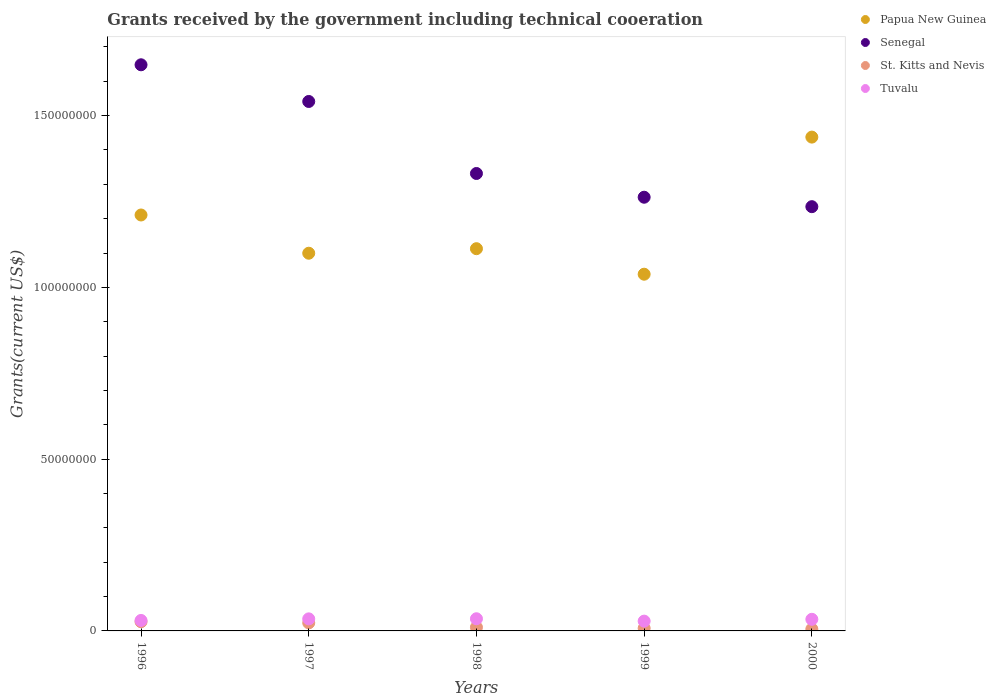Is the number of dotlines equal to the number of legend labels?
Provide a succinct answer. Yes. What is the total grants received by the government in Tuvalu in 1999?
Ensure brevity in your answer.  2.85e+06. Across all years, what is the maximum total grants received by the government in Senegal?
Provide a succinct answer. 1.65e+08. Across all years, what is the minimum total grants received by the government in Papua New Guinea?
Offer a very short reply. 1.04e+08. What is the total total grants received by the government in Tuvalu in the graph?
Your answer should be compact. 1.63e+07. What is the difference between the total grants received by the government in Tuvalu in 1997 and that in 1998?
Your answer should be compact. -3.00e+04. What is the difference between the total grants received by the government in Tuvalu in 1999 and the total grants received by the government in Senegal in 1996?
Your response must be concise. -1.62e+08. What is the average total grants received by the government in St. Kitts and Nevis per year?
Make the answer very short. 1.48e+06. In the year 1999, what is the difference between the total grants received by the government in Papua New Guinea and total grants received by the government in Senegal?
Provide a succinct answer. -2.24e+07. In how many years, is the total grants received by the government in St. Kitts and Nevis greater than 130000000 US$?
Your response must be concise. 0. What is the ratio of the total grants received by the government in St. Kitts and Nevis in 1998 to that in 1999?
Your answer should be compact. 1.35. Is the total grants received by the government in Papua New Guinea in 1996 less than that in 1998?
Offer a terse response. No. What is the difference between the highest and the second highest total grants received by the government in Senegal?
Make the answer very short. 1.07e+07. What is the difference between the highest and the lowest total grants received by the government in Papua New Guinea?
Offer a terse response. 3.99e+07. In how many years, is the total grants received by the government in Tuvalu greater than the average total grants received by the government in Tuvalu taken over all years?
Offer a very short reply. 3. Is the total grants received by the government in Senegal strictly less than the total grants received by the government in Papua New Guinea over the years?
Give a very brief answer. No. Does the graph contain grids?
Keep it short and to the point. No. Where does the legend appear in the graph?
Your response must be concise. Top right. How many legend labels are there?
Provide a succinct answer. 4. What is the title of the graph?
Provide a short and direct response. Grants received by the government including technical cooeration. What is the label or title of the Y-axis?
Offer a terse response. Grants(current US$). What is the Grants(current US$) in Papua New Guinea in 1996?
Provide a succinct answer. 1.21e+08. What is the Grants(current US$) in Senegal in 1996?
Your answer should be compact. 1.65e+08. What is the Grants(current US$) in St. Kitts and Nevis in 1996?
Keep it short and to the point. 2.67e+06. What is the Grants(current US$) in Tuvalu in 1996?
Provide a succinct answer. 3.05e+06. What is the Grants(current US$) of Papua New Guinea in 1997?
Your answer should be very brief. 1.10e+08. What is the Grants(current US$) in Senegal in 1997?
Offer a very short reply. 1.54e+08. What is the Grants(current US$) of St. Kitts and Nevis in 1997?
Your answer should be very brief. 2.34e+06. What is the Grants(current US$) of Tuvalu in 1997?
Your response must be concise. 3.51e+06. What is the Grants(current US$) in Papua New Guinea in 1998?
Give a very brief answer. 1.11e+08. What is the Grants(current US$) in Senegal in 1998?
Ensure brevity in your answer.  1.33e+08. What is the Grants(current US$) in St. Kitts and Nevis in 1998?
Offer a terse response. 1.05e+06. What is the Grants(current US$) in Tuvalu in 1998?
Your answer should be compact. 3.54e+06. What is the Grants(current US$) of Papua New Guinea in 1999?
Your response must be concise. 1.04e+08. What is the Grants(current US$) of Senegal in 1999?
Keep it short and to the point. 1.26e+08. What is the Grants(current US$) in St. Kitts and Nevis in 1999?
Your response must be concise. 7.80e+05. What is the Grants(current US$) in Tuvalu in 1999?
Keep it short and to the point. 2.85e+06. What is the Grants(current US$) of Papua New Guinea in 2000?
Make the answer very short. 1.44e+08. What is the Grants(current US$) in Senegal in 2000?
Provide a short and direct response. 1.23e+08. What is the Grants(current US$) of Tuvalu in 2000?
Ensure brevity in your answer.  3.38e+06. Across all years, what is the maximum Grants(current US$) of Papua New Guinea?
Ensure brevity in your answer.  1.44e+08. Across all years, what is the maximum Grants(current US$) in Senegal?
Your response must be concise. 1.65e+08. Across all years, what is the maximum Grants(current US$) of St. Kitts and Nevis?
Your answer should be compact. 2.67e+06. Across all years, what is the maximum Grants(current US$) in Tuvalu?
Offer a very short reply. 3.54e+06. Across all years, what is the minimum Grants(current US$) in Papua New Guinea?
Offer a very short reply. 1.04e+08. Across all years, what is the minimum Grants(current US$) in Senegal?
Offer a very short reply. 1.23e+08. Across all years, what is the minimum Grants(current US$) in Tuvalu?
Your response must be concise. 2.85e+06. What is the total Grants(current US$) in Papua New Guinea in the graph?
Keep it short and to the point. 5.90e+08. What is the total Grants(current US$) of Senegal in the graph?
Your answer should be compact. 7.02e+08. What is the total Grants(current US$) in St. Kitts and Nevis in the graph?
Ensure brevity in your answer.  7.39e+06. What is the total Grants(current US$) of Tuvalu in the graph?
Your response must be concise. 1.63e+07. What is the difference between the Grants(current US$) in Papua New Guinea in 1996 and that in 1997?
Keep it short and to the point. 1.11e+07. What is the difference between the Grants(current US$) of Senegal in 1996 and that in 1997?
Your answer should be very brief. 1.07e+07. What is the difference between the Grants(current US$) of Tuvalu in 1996 and that in 1997?
Your response must be concise. -4.60e+05. What is the difference between the Grants(current US$) in Papua New Guinea in 1996 and that in 1998?
Make the answer very short. 9.81e+06. What is the difference between the Grants(current US$) of Senegal in 1996 and that in 1998?
Keep it short and to the point. 3.16e+07. What is the difference between the Grants(current US$) of St. Kitts and Nevis in 1996 and that in 1998?
Ensure brevity in your answer.  1.62e+06. What is the difference between the Grants(current US$) of Tuvalu in 1996 and that in 1998?
Ensure brevity in your answer.  -4.90e+05. What is the difference between the Grants(current US$) of Papua New Guinea in 1996 and that in 1999?
Give a very brief answer. 1.72e+07. What is the difference between the Grants(current US$) of Senegal in 1996 and that in 1999?
Offer a very short reply. 3.86e+07. What is the difference between the Grants(current US$) of St. Kitts and Nevis in 1996 and that in 1999?
Give a very brief answer. 1.89e+06. What is the difference between the Grants(current US$) in Papua New Guinea in 1996 and that in 2000?
Provide a succinct answer. -2.27e+07. What is the difference between the Grants(current US$) of Senegal in 1996 and that in 2000?
Provide a short and direct response. 4.13e+07. What is the difference between the Grants(current US$) in St. Kitts and Nevis in 1996 and that in 2000?
Ensure brevity in your answer.  2.12e+06. What is the difference between the Grants(current US$) in Tuvalu in 1996 and that in 2000?
Your response must be concise. -3.30e+05. What is the difference between the Grants(current US$) of Papua New Guinea in 1997 and that in 1998?
Ensure brevity in your answer.  -1.32e+06. What is the difference between the Grants(current US$) in Senegal in 1997 and that in 1998?
Ensure brevity in your answer.  2.10e+07. What is the difference between the Grants(current US$) of St. Kitts and Nevis in 1997 and that in 1998?
Offer a very short reply. 1.29e+06. What is the difference between the Grants(current US$) in Tuvalu in 1997 and that in 1998?
Provide a short and direct response. -3.00e+04. What is the difference between the Grants(current US$) of Papua New Guinea in 1997 and that in 1999?
Offer a terse response. 6.11e+06. What is the difference between the Grants(current US$) in Senegal in 1997 and that in 1999?
Provide a succinct answer. 2.79e+07. What is the difference between the Grants(current US$) in St. Kitts and Nevis in 1997 and that in 1999?
Provide a succinct answer. 1.56e+06. What is the difference between the Grants(current US$) of Tuvalu in 1997 and that in 1999?
Give a very brief answer. 6.60e+05. What is the difference between the Grants(current US$) of Papua New Guinea in 1997 and that in 2000?
Give a very brief answer. -3.38e+07. What is the difference between the Grants(current US$) in Senegal in 1997 and that in 2000?
Provide a succinct answer. 3.06e+07. What is the difference between the Grants(current US$) in St. Kitts and Nevis in 1997 and that in 2000?
Provide a short and direct response. 1.79e+06. What is the difference between the Grants(current US$) of Papua New Guinea in 1998 and that in 1999?
Offer a very short reply. 7.43e+06. What is the difference between the Grants(current US$) in Senegal in 1998 and that in 1999?
Offer a very short reply. 6.91e+06. What is the difference between the Grants(current US$) of St. Kitts and Nevis in 1998 and that in 1999?
Give a very brief answer. 2.70e+05. What is the difference between the Grants(current US$) in Tuvalu in 1998 and that in 1999?
Keep it short and to the point. 6.90e+05. What is the difference between the Grants(current US$) in Papua New Guinea in 1998 and that in 2000?
Make the answer very short. -3.25e+07. What is the difference between the Grants(current US$) of Senegal in 1998 and that in 2000?
Your answer should be very brief. 9.66e+06. What is the difference between the Grants(current US$) in Tuvalu in 1998 and that in 2000?
Make the answer very short. 1.60e+05. What is the difference between the Grants(current US$) of Papua New Guinea in 1999 and that in 2000?
Your answer should be compact. -3.99e+07. What is the difference between the Grants(current US$) in Senegal in 1999 and that in 2000?
Provide a succinct answer. 2.75e+06. What is the difference between the Grants(current US$) in Tuvalu in 1999 and that in 2000?
Keep it short and to the point. -5.30e+05. What is the difference between the Grants(current US$) in Papua New Guinea in 1996 and the Grants(current US$) in Senegal in 1997?
Provide a short and direct response. -3.30e+07. What is the difference between the Grants(current US$) in Papua New Guinea in 1996 and the Grants(current US$) in St. Kitts and Nevis in 1997?
Give a very brief answer. 1.19e+08. What is the difference between the Grants(current US$) in Papua New Guinea in 1996 and the Grants(current US$) in Tuvalu in 1997?
Your answer should be very brief. 1.18e+08. What is the difference between the Grants(current US$) of Senegal in 1996 and the Grants(current US$) of St. Kitts and Nevis in 1997?
Ensure brevity in your answer.  1.62e+08. What is the difference between the Grants(current US$) of Senegal in 1996 and the Grants(current US$) of Tuvalu in 1997?
Offer a very short reply. 1.61e+08. What is the difference between the Grants(current US$) of St. Kitts and Nevis in 1996 and the Grants(current US$) of Tuvalu in 1997?
Your answer should be compact. -8.40e+05. What is the difference between the Grants(current US$) in Papua New Guinea in 1996 and the Grants(current US$) in Senegal in 1998?
Offer a very short reply. -1.21e+07. What is the difference between the Grants(current US$) in Papua New Guinea in 1996 and the Grants(current US$) in St. Kitts and Nevis in 1998?
Ensure brevity in your answer.  1.20e+08. What is the difference between the Grants(current US$) of Papua New Guinea in 1996 and the Grants(current US$) of Tuvalu in 1998?
Keep it short and to the point. 1.18e+08. What is the difference between the Grants(current US$) of Senegal in 1996 and the Grants(current US$) of St. Kitts and Nevis in 1998?
Provide a short and direct response. 1.64e+08. What is the difference between the Grants(current US$) in Senegal in 1996 and the Grants(current US$) in Tuvalu in 1998?
Ensure brevity in your answer.  1.61e+08. What is the difference between the Grants(current US$) in St. Kitts and Nevis in 1996 and the Grants(current US$) in Tuvalu in 1998?
Your answer should be compact. -8.70e+05. What is the difference between the Grants(current US$) of Papua New Guinea in 1996 and the Grants(current US$) of Senegal in 1999?
Make the answer very short. -5.17e+06. What is the difference between the Grants(current US$) of Papua New Guinea in 1996 and the Grants(current US$) of St. Kitts and Nevis in 1999?
Your answer should be compact. 1.20e+08. What is the difference between the Grants(current US$) of Papua New Guinea in 1996 and the Grants(current US$) of Tuvalu in 1999?
Your answer should be very brief. 1.18e+08. What is the difference between the Grants(current US$) in Senegal in 1996 and the Grants(current US$) in St. Kitts and Nevis in 1999?
Your answer should be compact. 1.64e+08. What is the difference between the Grants(current US$) in Senegal in 1996 and the Grants(current US$) in Tuvalu in 1999?
Give a very brief answer. 1.62e+08. What is the difference between the Grants(current US$) in St. Kitts and Nevis in 1996 and the Grants(current US$) in Tuvalu in 1999?
Offer a terse response. -1.80e+05. What is the difference between the Grants(current US$) of Papua New Guinea in 1996 and the Grants(current US$) of Senegal in 2000?
Offer a very short reply. -2.42e+06. What is the difference between the Grants(current US$) in Papua New Guinea in 1996 and the Grants(current US$) in St. Kitts and Nevis in 2000?
Make the answer very short. 1.21e+08. What is the difference between the Grants(current US$) in Papua New Guinea in 1996 and the Grants(current US$) in Tuvalu in 2000?
Offer a terse response. 1.18e+08. What is the difference between the Grants(current US$) of Senegal in 1996 and the Grants(current US$) of St. Kitts and Nevis in 2000?
Ensure brevity in your answer.  1.64e+08. What is the difference between the Grants(current US$) of Senegal in 1996 and the Grants(current US$) of Tuvalu in 2000?
Offer a terse response. 1.61e+08. What is the difference between the Grants(current US$) in St. Kitts and Nevis in 1996 and the Grants(current US$) in Tuvalu in 2000?
Your response must be concise. -7.10e+05. What is the difference between the Grants(current US$) in Papua New Guinea in 1997 and the Grants(current US$) in Senegal in 1998?
Offer a terse response. -2.32e+07. What is the difference between the Grants(current US$) of Papua New Guinea in 1997 and the Grants(current US$) of St. Kitts and Nevis in 1998?
Offer a very short reply. 1.09e+08. What is the difference between the Grants(current US$) of Papua New Guinea in 1997 and the Grants(current US$) of Tuvalu in 1998?
Give a very brief answer. 1.06e+08. What is the difference between the Grants(current US$) of Senegal in 1997 and the Grants(current US$) of St. Kitts and Nevis in 1998?
Provide a short and direct response. 1.53e+08. What is the difference between the Grants(current US$) in Senegal in 1997 and the Grants(current US$) in Tuvalu in 1998?
Your answer should be compact. 1.51e+08. What is the difference between the Grants(current US$) in St. Kitts and Nevis in 1997 and the Grants(current US$) in Tuvalu in 1998?
Your response must be concise. -1.20e+06. What is the difference between the Grants(current US$) in Papua New Guinea in 1997 and the Grants(current US$) in Senegal in 1999?
Ensure brevity in your answer.  -1.63e+07. What is the difference between the Grants(current US$) of Papua New Guinea in 1997 and the Grants(current US$) of St. Kitts and Nevis in 1999?
Provide a succinct answer. 1.09e+08. What is the difference between the Grants(current US$) in Papua New Guinea in 1997 and the Grants(current US$) in Tuvalu in 1999?
Offer a very short reply. 1.07e+08. What is the difference between the Grants(current US$) in Senegal in 1997 and the Grants(current US$) in St. Kitts and Nevis in 1999?
Give a very brief answer. 1.53e+08. What is the difference between the Grants(current US$) in Senegal in 1997 and the Grants(current US$) in Tuvalu in 1999?
Keep it short and to the point. 1.51e+08. What is the difference between the Grants(current US$) in St. Kitts and Nevis in 1997 and the Grants(current US$) in Tuvalu in 1999?
Offer a very short reply. -5.10e+05. What is the difference between the Grants(current US$) of Papua New Guinea in 1997 and the Grants(current US$) of Senegal in 2000?
Make the answer very short. -1.36e+07. What is the difference between the Grants(current US$) in Papua New Guinea in 1997 and the Grants(current US$) in St. Kitts and Nevis in 2000?
Your answer should be very brief. 1.09e+08. What is the difference between the Grants(current US$) in Papua New Guinea in 1997 and the Grants(current US$) in Tuvalu in 2000?
Offer a terse response. 1.07e+08. What is the difference between the Grants(current US$) in Senegal in 1997 and the Grants(current US$) in St. Kitts and Nevis in 2000?
Provide a succinct answer. 1.54e+08. What is the difference between the Grants(current US$) of Senegal in 1997 and the Grants(current US$) of Tuvalu in 2000?
Your response must be concise. 1.51e+08. What is the difference between the Grants(current US$) in St. Kitts and Nevis in 1997 and the Grants(current US$) in Tuvalu in 2000?
Make the answer very short. -1.04e+06. What is the difference between the Grants(current US$) of Papua New Guinea in 1998 and the Grants(current US$) of Senegal in 1999?
Make the answer very short. -1.50e+07. What is the difference between the Grants(current US$) of Papua New Guinea in 1998 and the Grants(current US$) of St. Kitts and Nevis in 1999?
Make the answer very short. 1.10e+08. What is the difference between the Grants(current US$) in Papua New Guinea in 1998 and the Grants(current US$) in Tuvalu in 1999?
Your answer should be compact. 1.08e+08. What is the difference between the Grants(current US$) of Senegal in 1998 and the Grants(current US$) of St. Kitts and Nevis in 1999?
Offer a terse response. 1.32e+08. What is the difference between the Grants(current US$) in Senegal in 1998 and the Grants(current US$) in Tuvalu in 1999?
Your answer should be compact. 1.30e+08. What is the difference between the Grants(current US$) in St. Kitts and Nevis in 1998 and the Grants(current US$) in Tuvalu in 1999?
Keep it short and to the point. -1.80e+06. What is the difference between the Grants(current US$) in Papua New Guinea in 1998 and the Grants(current US$) in Senegal in 2000?
Offer a very short reply. -1.22e+07. What is the difference between the Grants(current US$) of Papua New Guinea in 1998 and the Grants(current US$) of St. Kitts and Nevis in 2000?
Keep it short and to the point. 1.11e+08. What is the difference between the Grants(current US$) of Papua New Guinea in 1998 and the Grants(current US$) of Tuvalu in 2000?
Keep it short and to the point. 1.08e+08. What is the difference between the Grants(current US$) in Senegal in 1998 and the Grants(current US$) in St. Kitts and Nevis in 2000?
Ensure brevity in your answer.  1.33e+08. What is the difference between the Grants(current US$) in Senegal in 1998 and the Grants(current US$) in Tuvalu in 2000?
Provide a succinct answer. 1.30e+08. What is the difference between the Grants(current US$) of St. Kitts and Nevis in 1998 and the Grants(current US$) of Tuvalu in 2000?
Your response must be concise. -2.33e+06. What is the difference between the Grants(current US$) in Papua New Guinea in 1999 and the Grants(current US$) in Senegal in 2000?
Offer a terse response. -1.97e+07. What is the difference between the Grants(current US$) in Papua New Guinea in 1999 and the Grants(current US$) in St. Kitts and Nevis in 2000?
Offer a very short reply. 1.03e+08. What is the difference between the Grants(current US$) in Papua New Guinea in 1999 and the Grants(current US$) in Tuvalu in 2000?
Make the answer very short. 1.00e+08. What is the difference between the Grants(current US$) of Senegal in 1999 and the Grants(current US$) of St. Kitts and Nevis in 2000?
Offer a terse response. 1.26e+08. What is the difference between the Grants(current US$) of Senegal in 1999 and the Grants(current US$) of Tuvalu in 2000?
Ensure brevity in your answer.  1.23e+08. What is the difference between the Grants(current US$) of St. Kitts and Nevis in 1999 and the Grants(current US$) of Tuvalu in 2000?
Provide a short and direct response. -2.60e+06. What is the average Grants(current US$) in Papua New Guinea per year?
Provide a succinct answer. 1.18e+08. What is the average Grants(current US$) of Senegal per year?
Your response must be concise. 1.40e+08. What is the average Grants(current US$) of St. Kitts and Nevis per year?
Provide a succinct answer. 1.48e+06. What is the average Grants(current US$) in Tuvalu per year?
Offer a terse response. 3.27e+06. In the year 1996, what is the difference between the Grants(current US$) of Papua New Guinea and Grants(current US$) of Senegal?
Provide a short and direct response. -4.37e+07. In the year 1996, what is the difference between the Grants(current US$) of Papua New Guinea and Grants(current US$) of St. Kitts and Nevis?
Your answer should be compact. 1.18e+08. In the year 1996, what is the difference between the Grants(current US$) in Papua New Guinea and Grants(current US$) in Tuvalu?
Make the answer very short. 1.18e+08. In the year 1996, what is the difference between the Grants(current US$) in Senegal and Grants(current US$) in St. Kitts and Nevis?
Keep it short and to the point. 1.62e+08. In the year 1996, what is the difference between the Grants(current US$) of Senegal and Grants(current US$) of Tuvalu?
Make the answer very short. 1.62e+08. In the year 1996, what is the difference between the Grants(current US$) of St. Kitts and Nevis and Grants(current US$) of Tuvalu?
Provide a succinct answer. -3.80e+05. In the year 1997, what is the difference between the Grants(current US$) in Papua New Guinea and Grants(current US$) in Senegal?
Your answer should be very brief. -4.42e+07. In the year 1997, what is the difference between the Grants(current US$) of Papua New Guinea and Grants(current US$) of St. Kitts and Nevis?
Ensure brevity in your answer.  1.08e+08. In the year 1997, what is the difference between the Grants(current US$) of Papua New Guinea and Grants(current US$) of Tuvalu?
Offer a very short reply. 1.06e+08. In the year 1997, what is the difference between the Grants(current US$) of Senegal and Grants(current US$) of St. Kitts and Nevis?
Make the answer very short. 1.52e+08. In the year 1997, what is the difference between the Grants(current US$) in Senegal and Grants(current US$) in Tuvalu?
Ensure brevity in your answer.  1.51e+08. In the year 1997, what is the difference between the Grants(current US$) of St. Kitts and Nevis and Grants(current US$) of Tuvalu?
Provide a short and direct response. -1.17e+06. In the year 1998, what is the difference between the Grants(current US$) of Papua New Guinea and Grants(current US$) of Senegal?
Offer a very short reply. -2.19e+07. In the year 1998, what is the difference between the Grants(current US$) in Papua New Guinea and Grants(current US$) in St. Kitts and Nevis?
Provide a short and direct response. 1.10e+08. In the year 1998, what is the difference between the Grants(current US$) in Papua New Guinea and Grants(current US$) in Tuvalu?
Keep it short and to the point. 1.08e+08. In the year 1998, what is the difference between the Grants(current US$) of Senegal and Grants(current US$) of St. Kitts and Nevis?
Give a very brief answer. 1.32e+08. In the year 1998, what is the difference between the Grants(current US$) of Senegal and Grants(current US$) of Tuvalu?
Your response must be concise. 1.30e+08. In the year 1998, what is the difference between the Grants(current US$) in St. Kitts and Nevis and Grants(current US$) in Tuvalu?
Your response must be concise. -2.49e+06. In the year 1999, what is the difference between the Grants(current US$) of Papua New Guinea and Grants(current US$) of Senegal?
Your answer should be very brief. -2.24e+07. In the year 1999, what is the difference between the Grants(current US$) in Papua New Guinea and Grants(current US$) in St. Kitts and Nevis?
Your answer should be very brief. 1.03e+08. In the year 1999, what is the difference between the Grants(current US$) in Papua New Guinea and Grants(current US$) in Tuvalu?
Give a very brief answer. 1.01e+08. In the year 1999, what is the difference between the Grants(current US$) of Senegal and Grants(current US$) of St. Kitts and Nevis?
Your answer should be compact. 1.25e+08. In the year 1999, what is the difference between the Grants(current US$) of Senegal and Grants(current US$) of Tuvalu?
Your response must be concise. 1.23e+08. In the year 1999, what is the difference between the Grants(current US$) in St. Kitts and Nevis and Grants(current US$) in Tuvalu?
Make the answer very short. -2.07e+06. In the year 2000, what is the difference between the Grants(current US$) in Papua New Guinea and Grants(current US$) in Senegal?
Provide a short and direct response. 2.02e+07. In the year 2000, what is the difference between the Grants(current US$) in Papua New Guinea and Grants(current US$) in St. Kitts and Nevis?
Offer a very short reply. 1.43e+08. In the year 2000, what is the difference between the Grants(current US$) of Papua New Guinea and Grants(current US$) of Tuvalu?
Give a very brief answer. 1.40e+08. In the year 2000, what is the difference between the Grants(current US$) in Senegal and Grants(current US$) in St. Kitts and Nevis?
Your response must be concise. 1.23e+08. In the year 2000, what is the difference between the Grants(current US$) of Senegal and Grants(current US$) of Tuvalu?
Provide a short and direct response. 1.20e+08. In the year 2000, what is the difference between the Grants(current US$) in St. Kitts and Nevis and Grants(current US$) in Tuvalu?
Your answer should be very brief. -2.83e+06. What is the ratio of the Grants(current US$) in Papua New Guinea in 1996 to that in 1997?
Your response must be concise. 1.1. What is the ratio of the Grants(current US$) of Senegal in 1996 to that in 1997?
Offer a terse response. 1.07. What is the ratio of the Grants(current US$) in St. Kitts and Nevis in 1996 to that in 1997?
Give a very brief answer. 1.14. What is the ratio of the Grants(current US$) of Tuvalu in 1996 to that in 1997?
Give a very brief answer. 0.87. What is the ratio of the Grants(current US$) in Papua New Guinea in 1996 to that in 1998?
Ensure brevity in your answer.  1.09. What is the ratio of the Grants(current US$) in Senegal in 1996 to that in 1998?
Offer a terse response. 1.24. What is the ratio of the Grants(current US$) in St. Kitts and Nevis in 1996 to that in 1998?
Offer a very short reply. 2.54. What is the ratio of the Grants(current US$) in Tuvalu in 1996 to that in 1998?
Give a very brief answer. 0.86. What is the ratio of the Grants(current US$) in Papua New Guinea in 1996 to that in 1999?
Offer a very short reply. 1.17. What is the ratio of the Grants(current US$) of Senegal in 1996 to that in 1999?
Provide a short and direct response. 1.31. What is the ratio of the Grants(current US$) in St. Kitts and Nevis in 1996 to that in 1999?
Ensure brevity in your answer.  3.42. What is the ratio of the Grants(current US$) in Tuvalu in 1996 to that in 1999?
Offer a terse response. 1.07. What is the ratio of the Grants(current US$) in Papua New Guinea in 1996 to that in 2000?
Provide a succinct answer. 0.84. What is the ratio of the Grants(current US$) in Senegal in 1996 to that in 2000?
Provide a short and direct response. 1.33. What is the ratio of the Grants(current US$) of St. Kitts and Nevis in 1996 to that in 2000?
Offer a terse response. 4.85. What is the ratio of the Grants(current US$) of Tuvalu in 1996 to that in 2000?
Your answer should be compact. 0.9. What is the ratio of the Grants(current US$) of Papua New Guinea in 1997 to that in 1998?
Your answer should be very brief. 0.99. What is the ratio of the Grants(current US$) of Senegal in 1997 to that in 1998?
Ensure brevity in your answer.  1.16. What is the ratio of the Grants(current US$) in St. Kitts and Nevis in 1997 to that in 1998?
Your response must be concise. 2.23. What is the ratio of the Grants(current US$) in Papua New Guinea in 1997 to that in 1999?
Offer a very short reply. 1.06. What is the ratio of the Grants(current US$) in Senegal in 1997 to that in 1999?
Give a very brief answer. 1.22. What is the ratio of the Grants(current US$) in St. Kitts and Nevis in 1997 to that in 1999?
Your answer should be compact. 3. What is the ratio of the Grants(current US$) in Tuvalu in 1997 to that in 1999?
Offer a terse response. 1.23. What is the ratio of the Grants(current US$) in Papua New Guinea in 1997 to that in 2000?
Your answer should be very brief. 0.76. What is the ratio of the Grants(current US$) of Senegal in 1997 to that in 2000?
Your response must be concise. 1.25. What is the ratio of the Grants(current US$) of St. Kitts and Nevis in 1997 to that in 2000?
Ensure brevity in your answer.  4.25. What is the ratio of the Grants(current US$) of Tuvalu in 1997 to that in 2000?
Your answer should be very brief. 1.04. What is the ratio of the Grants(current US$) of Papua New Guinea in 1998 to that in 1999?
Offer a terse response. 1.07. What is the ratio of the Grants(current US$) in Senegal in 1998 to that in 1999?
Your answer should be very brief. 1.05. What is the ratio of the Grants(current US$) of St. Kitts and Nevis in 1998 to that in 1999?
Make the answer very short. 1.35. What is the ratio of the Grants(current US$) in Tuvalu in 1998 to that in 1999?
Make the answer very short. 1.24. What is the ratio of the Grants(current US$) in Papua New Guinea in 1998 to that in 2000?
Give a very brief answer. 0.77. What is the ratio of the Grants(current US$) in Senegal in 1998 to that in 2000?
Make the answer very short. 1.08. What is the ratio of the Grants(current US$) of St. Kitts and Nevis in 1998 to that in 2000?
Offer a terse response. 1.91. What is the ratio of the Grants(current US$) of Tuvalu in 1998 to that in 2000?
Your response must be concise. 1.05. What is the ratio of the Grants(current US$) of Papua New Guinea in 1999 to that in 2000?
Keep it short and to the point. 0.72. What is the ratio of the Grants(current US$) in Senegal in 1999 to that in 2000?
Your response must be concise. 1.02. What is the ratio of the Grants(current US$) in St. Kitts and Nevis in 1999 to that in 2000?
Your answer should be compact. 1.42. What is the ratio of the Grants(current US$) in Tuvalu in 1999 to that in 2000?
Ensure brevity in your answer.  0.84. What is the difference between the highest and the second highest Grants(current US$) in Papua New Guinea?
Your answer should be compact. 2.27e+07. What is the difference between the highest and the second highest Grants(current US$) of Senegal?
Make the answer very short. 1.07e+07. What is the difference between the highest and the second highest Grants(current US$) in Tuvalu?
Ensure brevity in your answer.  3.00e+04. What is the difference between the highest and the lowest Grants(current US$) in Papua New Guinea?
Your response must be concise. 3.99e+07. What is the difference between the highest and the lowest Grants(current US$) of Senegal?
Offer a terse response. 4.13e+07. What is the difference between the highest and the lowest Grants(current US$) of St. Kitts and Nevis?
Offer a terse response. 2.12e+06. What is the difference between the highest and the lowest Grants(current US$) in Tuvalu?
Ensure brevity in your answer.  6.90e+05. 